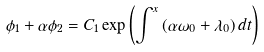Convert formula to latex. <formula><loc_0><loc_0><loc_500><loc_500>\phi _ { 1 } + \alpha \phi _ { 2 } = C _ { 1 } \exp \left ( \int ^ { x } \left ( \alpha \omega _ { 0 } + \lambda _ { 0 } \right ) d t \right )</formula> 